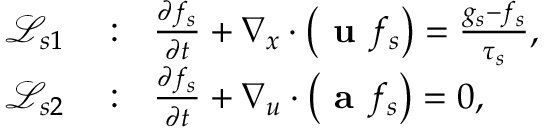Convert formula to latex. <formula><loc_0><loc_0><loc_500><loc_500>\begin{array} { r l } { \mathcal { L } _ { s 1 } } & \colon \frac { \partial f _ { s } } { \partial t } + \nabla _ { x } \cdot \left ( u f _ { s } \right ) = \frac { g _ { s } - f _ { s } } { \tau _ { s } } , } \\ { \mathcal { L } _ { s 2 } } & \colon \frac { \partial f _ { s } } { \partial t } + \nabla _ { u } \cdot \left ( a f _ { s } \right ) = 0 , } \end{array}</formula> 